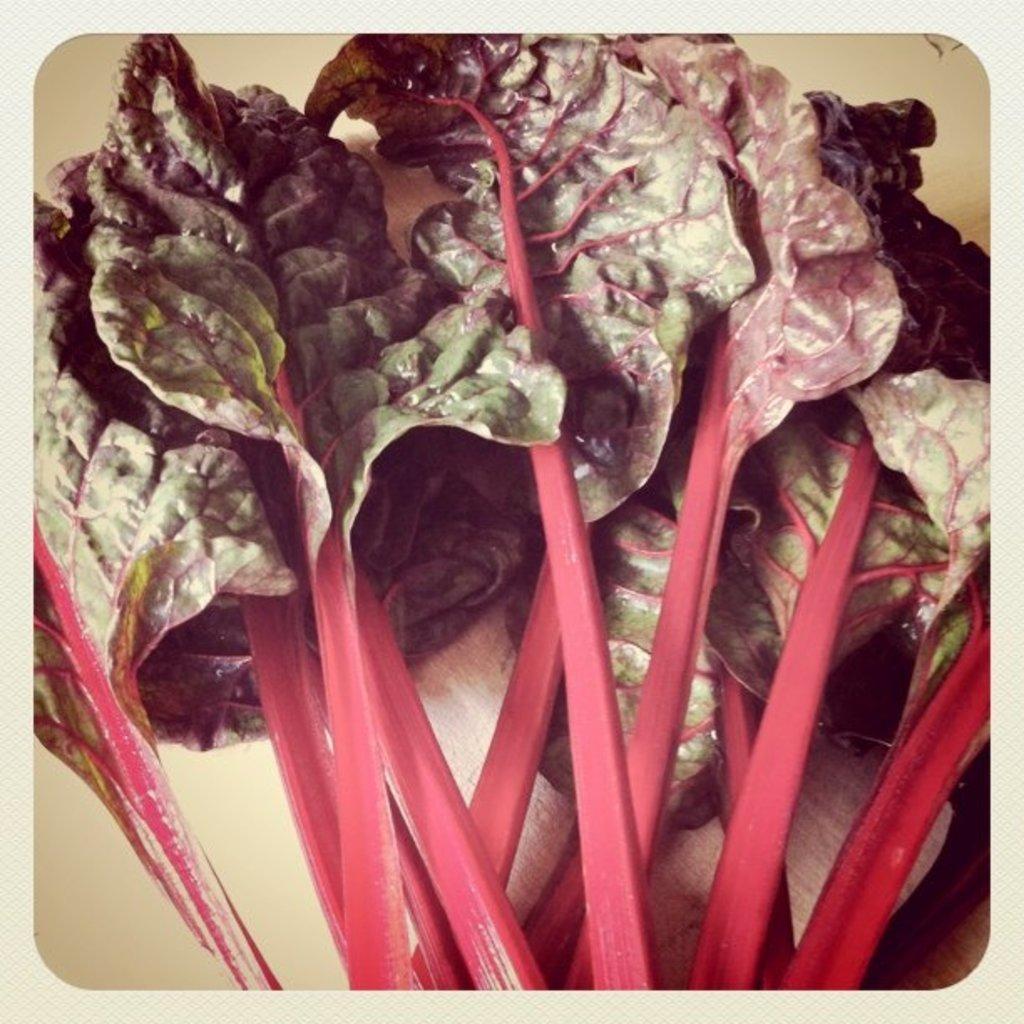Can you describe this image briefly? This image consists of some leafy vegetables. They are in green and pink color. 